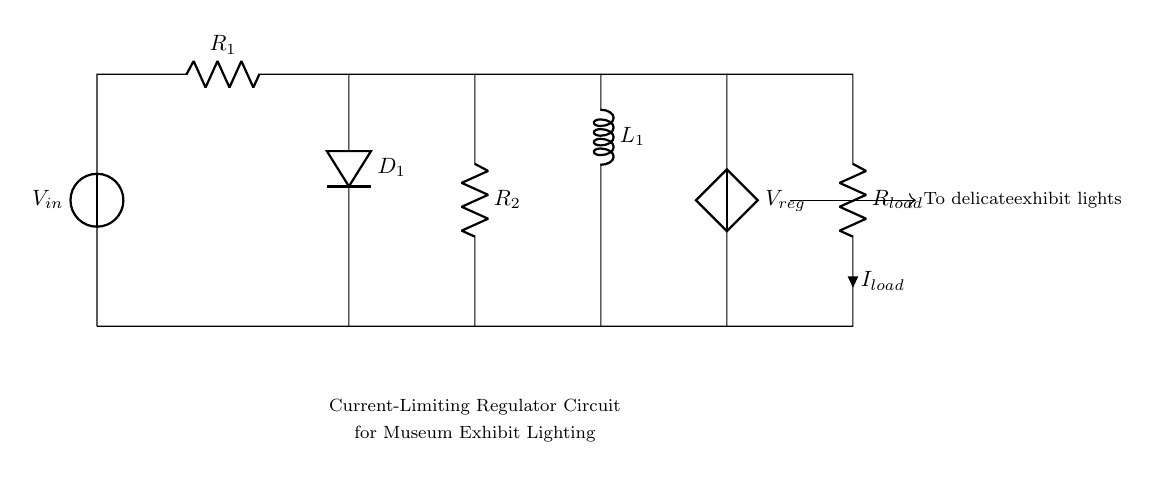What is the input voltage of the circuit? The input voltage is indicated by the label on the voltage source V_{in}, which provides the necessary potential difference to the circuit.
Answer: V_{in} What component limits the current in this circuit? The current-limiting function is primarily achieved through the resistor R_1, which restricts the flow of current in the circuit and protects sensitive components.
Answer: R_1 How many resistors are present in the circuit? By counting the labeled resistors in the diagram, we see that there are two resistors: R_1 and R_2.
Answer: 2 What type of component is D_1? The component labeled D_1 is a diode, which allows current to flow in one direction while blocking it in the opposite direction, thus protecting the circuit from potential negative voltage effects.
Answer: Diode What is the purpose of the inductor L_1 in this circuit? The inductor L_1 is used to filter or smooth out variations in current, which is important for providing a stable supply to delicate lighting, helping to maintain consistent brightness.
Answer: Smoothing What is the load current designated as in the diagram? The load current drawn from the resistor labeled R_{load} is indicated by i, which represents the flow of current through this specific component.
Answer: I_{load} What is the output voltage level referred to in the circuit? The output voltage level is represented by V_{reg} in the schematic, which signifies the regulated voltage being delivered to the lighting after processing through the circuit.
Answer: V_{reg} 